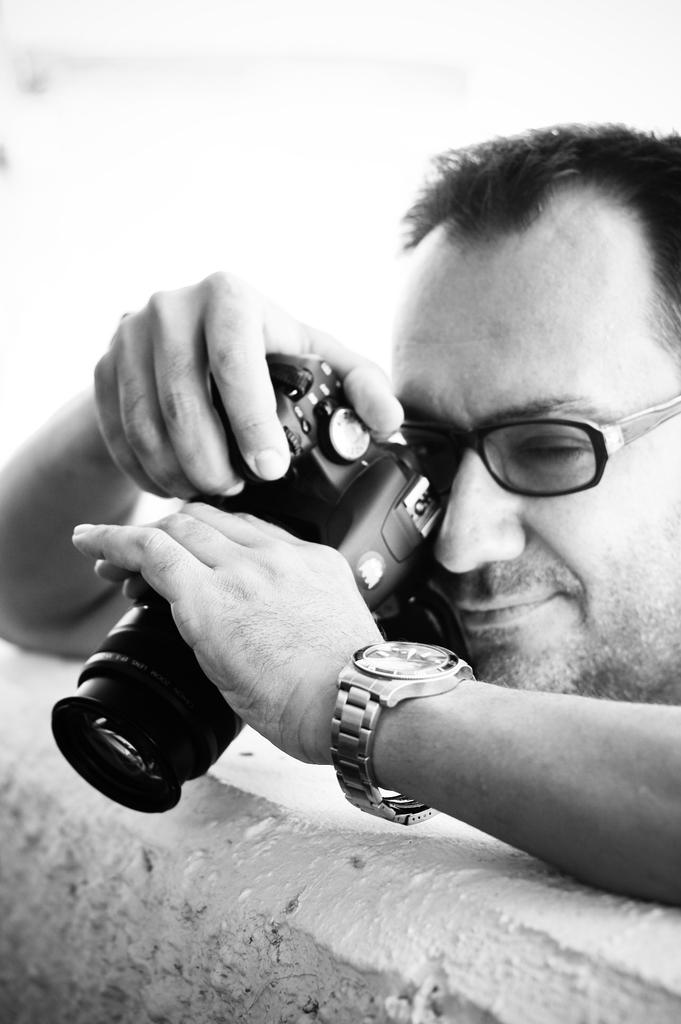What is the color scheme of the image? The picture is black and white. Who is present in the image? There is a man in the image. What is the man doing in the image? The man is taking pictures with a camera. How is the camera positioned in the image? The camera is leaning on a wall. What type of throat lozenges can be seen in the image? There are no throat lozenges present in the image. What kind of shock can be observed in the image? There is no shock present in the image. 